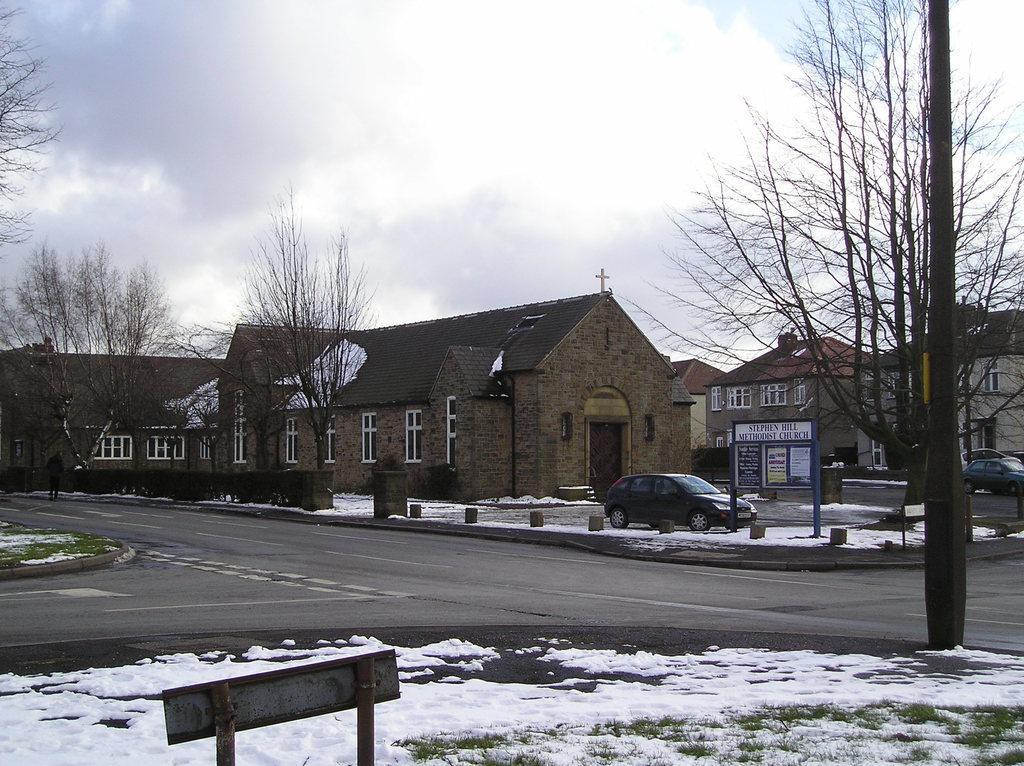Please provide a concise description of this image. At the bottom I can see a board and ice. In the middle In can see vehicles on the road, fence, trees, houses and windows. On the top I can see the sky. This image is taken during a day. 